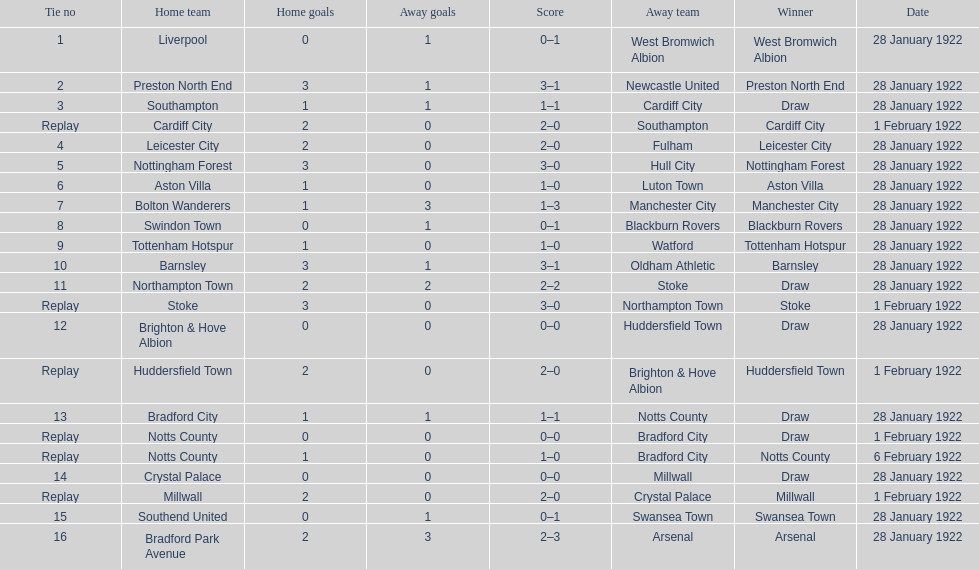What home team had the same score as aston villa on january 28th, 1922? Tottenham Hotspur. 